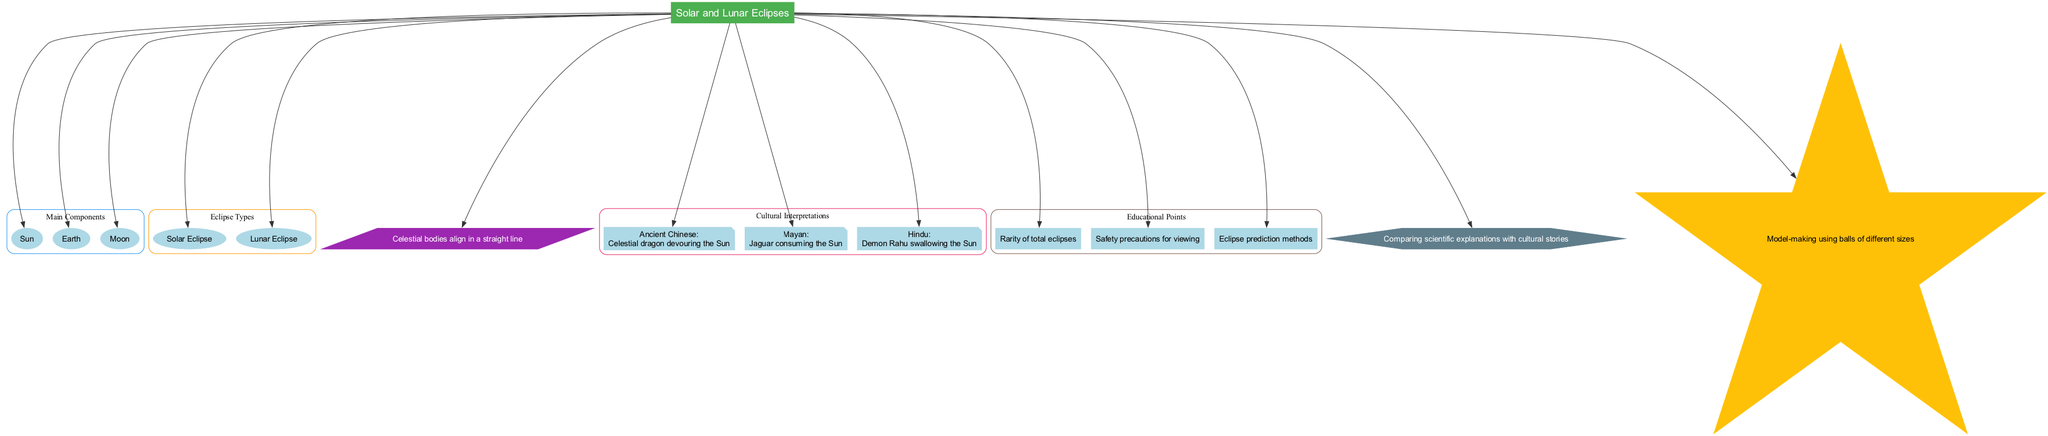What is the central concept of the diagram? The central concept is a key node in the diagram, labeled "Solar and Lunar Eclipses." This node serves as the main topic that connects various related elements in the diagram.
Answer: Solar and Lunar Eclipses How many main components are listed in the diagram? There are three main components shown in a specific cluster of nodes, clearly delineated in the diagram. By counting the nodes in the "Main Components" cluster, we establish the quantity.
Answer: 3 What does the diagram state about cultural interpretations? The diagram contains a cluster dedicated to cultural interpretations, listing multiple cultures and their beliefs. The content of this cluster reveals varying cultural stories related to eclipses.
Answer: Celestial dragon devouring the Sun, Jaguar consuming the Sun, Demon Rahu swallowing the Sun What is the name of one educational point included in the diagram? The diagram presents a few educational points, highlighted in a dedicated section. By examining the nodes in the "Educational Points" cluster, one can identify different educational aspects.
Answer: Rarity of total eclipses Which type of eclipse involves the Earth blocking the Sun? The diagram explicitly lists two types of eclipses. Evaluating the relationship between the Sun, Earth, and Moon reveals that the Earth blocking the Sun corresponds to one specific type.
Answer: Solar Eclipse What is the significance of the alignment description in the diagram? The alignment description node clarifies the relationship between the celestial bodies during an eclipse event, which involves these bodies aligning in a straight line. The explanation concerns how such alignments result in either solar or lunar eclipses.
Answer: Celestial bodies align in a straight line What cultural belief is associated with eclipses in the Mayan tradition? The cultural interpretations section lists specific beliefs linked to various cultures. By focusing on the Mayan node, one can extract the associated belief regarding eclipses.
Answer: Jaguar consuming the Sun What classroom activity is suggested in the diagram for teaching the concepts of eclipses? The diagram concludes with a node that details a specific classroom activity aimed at promoting understanding of the eclipse phenomenon through a hands-on approach. This can be found at the bottom of the diagram.
Answer: Model-making using balls of different sizes 